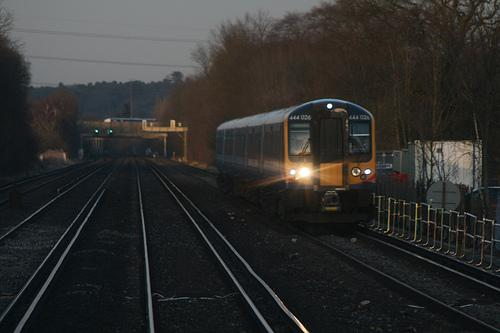What is one unique detail about the green transformer boxes in the image? There is a red warning sign on one of the green transformer boxes. Can you list some of the objects that can be found within this image? Train, tracks, overpass, vehicles, windows, lights, fence, rocks, transformer boxes, power lines, metal railing, and a tree. Explain the positioning of the vehicles in the image. There are vehicles on the overpass traveling over the train tracks. Count the number of front windows visible on the train. There are two front windows visible on the train. What is the color combination seen on the train in the image? The train is blue and yellow. What kind of fencing can be seen near the train tracks? A metal fence can be seen along the train tracks. What kind of train is depicted in this image? A commuter train is depicted in this image. Describe the condition of the tree next to the train tracks. The tree next to the tracks has some broken limbs. What color are the power lines over the train tracks in this image? The power lines are black. Explain what the configuration of the train tracks looks like. There are several train tracks running parallel to each other. Isn't that cloud shaped like a rabbit above the bridge? The rabbit-shaped cloud seems to be hopping in the sky. No, it's not mentioned in the image. Wasn't it surprising to see a UFO hovering above the train? There's a UFO right above the power lines casting a green light. The instruction is misleading as there is no mention of a UFO or any green light. The sentence structure includes a rhetorical question about the viewer's feelings (surprise) and a declarative sentence describing the purported UFO and its position. 